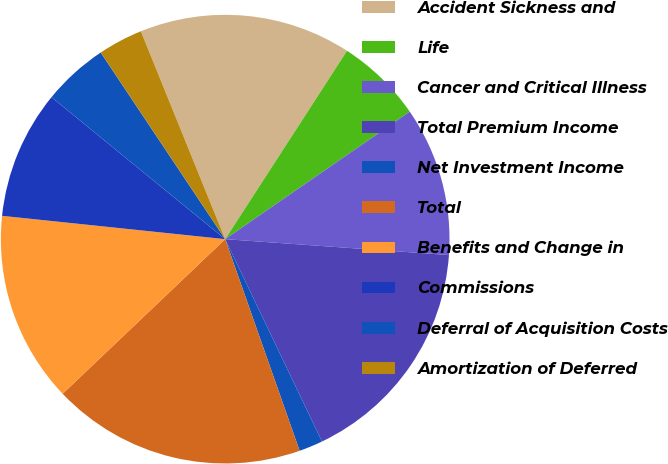Convert chart. <chart><loc_0><loc_0><loc_500><loc_500><pie_chart><fcel>Accident Sickness and<fcel>Life<fcel>Cancer and Critical Illness<fcel>Total Premium Income<fcel>Net Investment Income<fcel>Total<fcel>Benefits and Change in<fcel>Commissions<fcel>Deferral of Acquisition Costs<fcel>Amortization of Deferred<nl><fcel>15.27%<fcel>6.24%<fcel>10.75%<fcel>16.77%<fcel>1.72%<fcel>18.28%<fcel>13.76%<fcel>9.25%<fcel>4.73%<fcel>3.23%<nl></chart> 